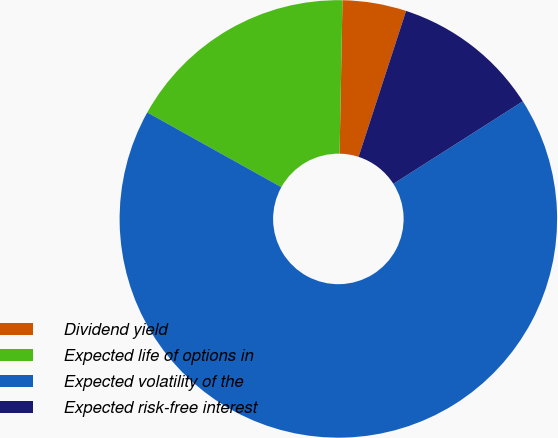<chart> <loc_0><loc_0><loc_500><loc_500><pie_chart><fcel>Dividend yield<fcel>Expected life of options in<fcel>Expected volatility of the<fcel>Expected risk-free interest<nl><fcel>4.71%<fcel>17.21%<fcel>67.13%<fcel>10.96%<nl></chart> 